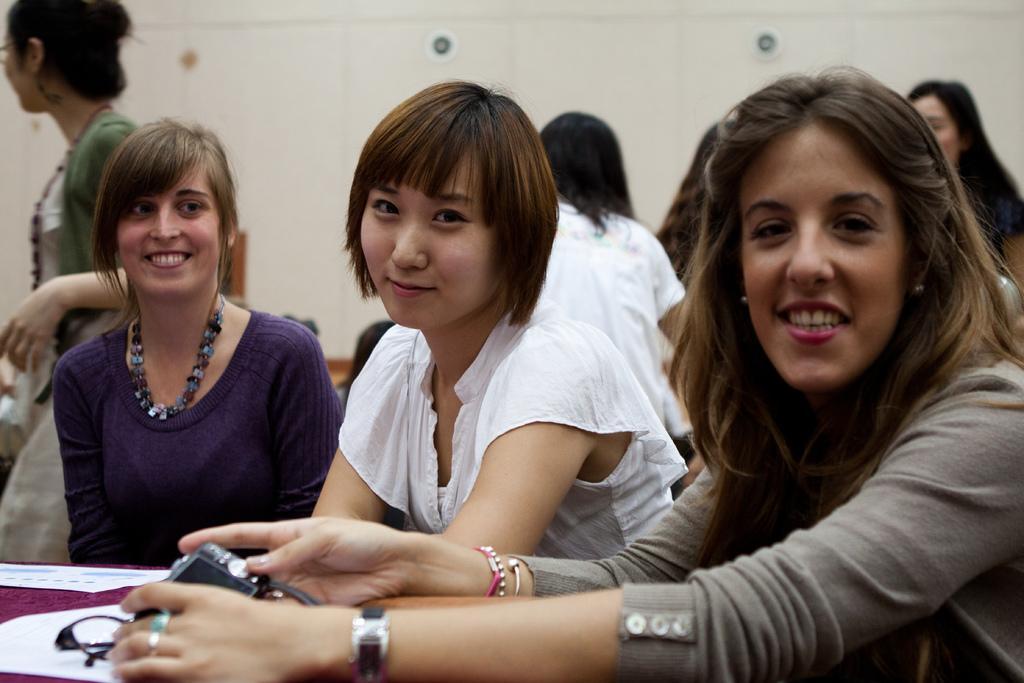Could you give a brief overview of what you see in this image? In this image we can see group of women. one woman is holding a camera in her hand. In the left side of the image we can see a woman wearing spectacles is standing. In the background we can see some lights on wall 